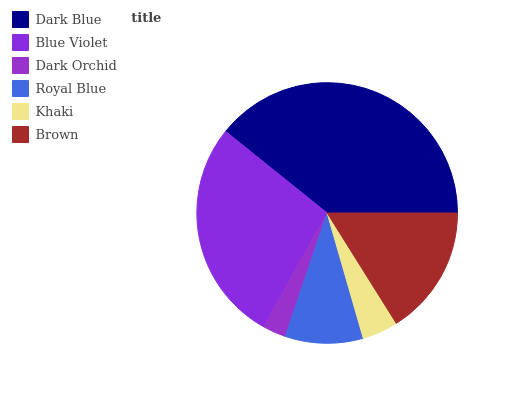Is Dark Orchid the minimum?
Answer yes or no. Yes. Is Dark Blue the maximum?
Answer yes or no. Yes. Is Blue Violet the minimum?
Answer yes or no. No. Is Blue Violet the maximum?
Answer yes or no. No. Is Dark Blue greater than Blue Violet?
Answer yes or no. Yes. Is Blue Violet less than Dark Blue?
Answer yes or no. Yes. Is Blue Violet greater than Dark Blue?
Answer yes or no. No. Is Dark Blue less than Blue Violet?
Answer yes or no. No. Is Brown the high median?
Answer yes or no. Yes. Is Royal Blue the low median?
Answer yes or no. Yes. Is Dark Orchid the high median?
Answer yes or no. No. Is Dark Blue the low median?
Answer yes or no. No. 